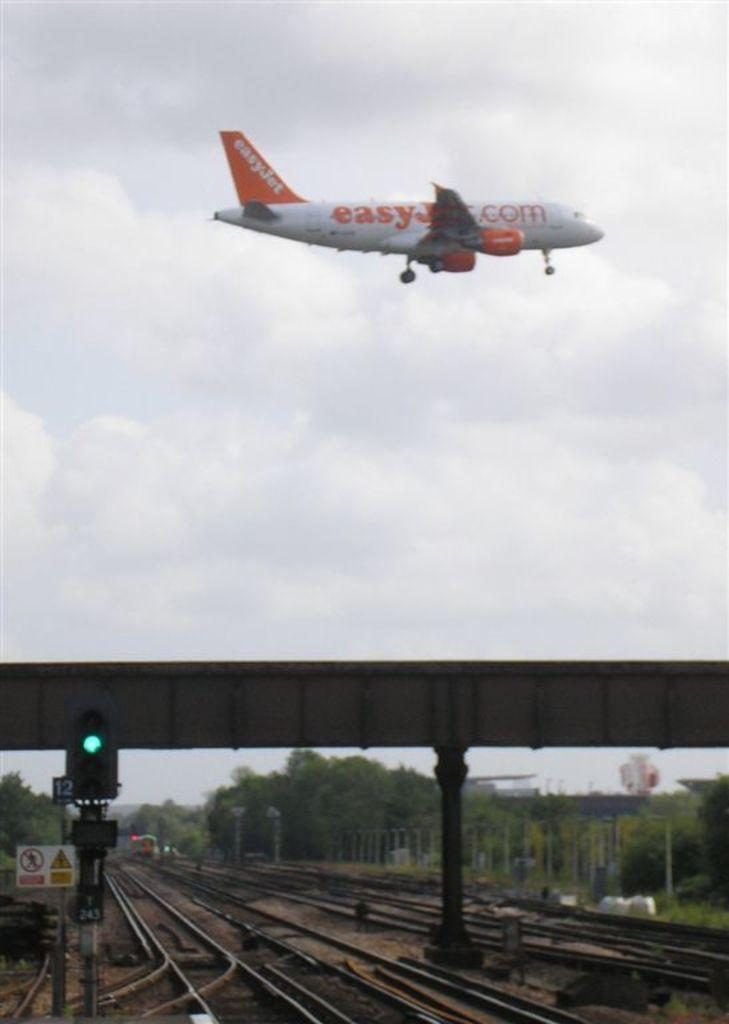What can be seen at the bottom of the image? There are railway tracks at the bottom of the image. What is present near the railway tracks? There is a signal pole in the image. What other object can be seen in the image? There is a sign board in the image. What type of structure is visible in the image? There is a flyover in the image. What type of vegetation is present in the image? There are trees in the image. What can be seen in the sky in the image? There is an aeroplane in the sky. How many eggs are being carried by the aeroplane in the image? There are no eggs visible in the image, and the aeroplane is not shown carrying any eggs. Is there a bike trail visible in the image? There is no bike trail present in the image. 